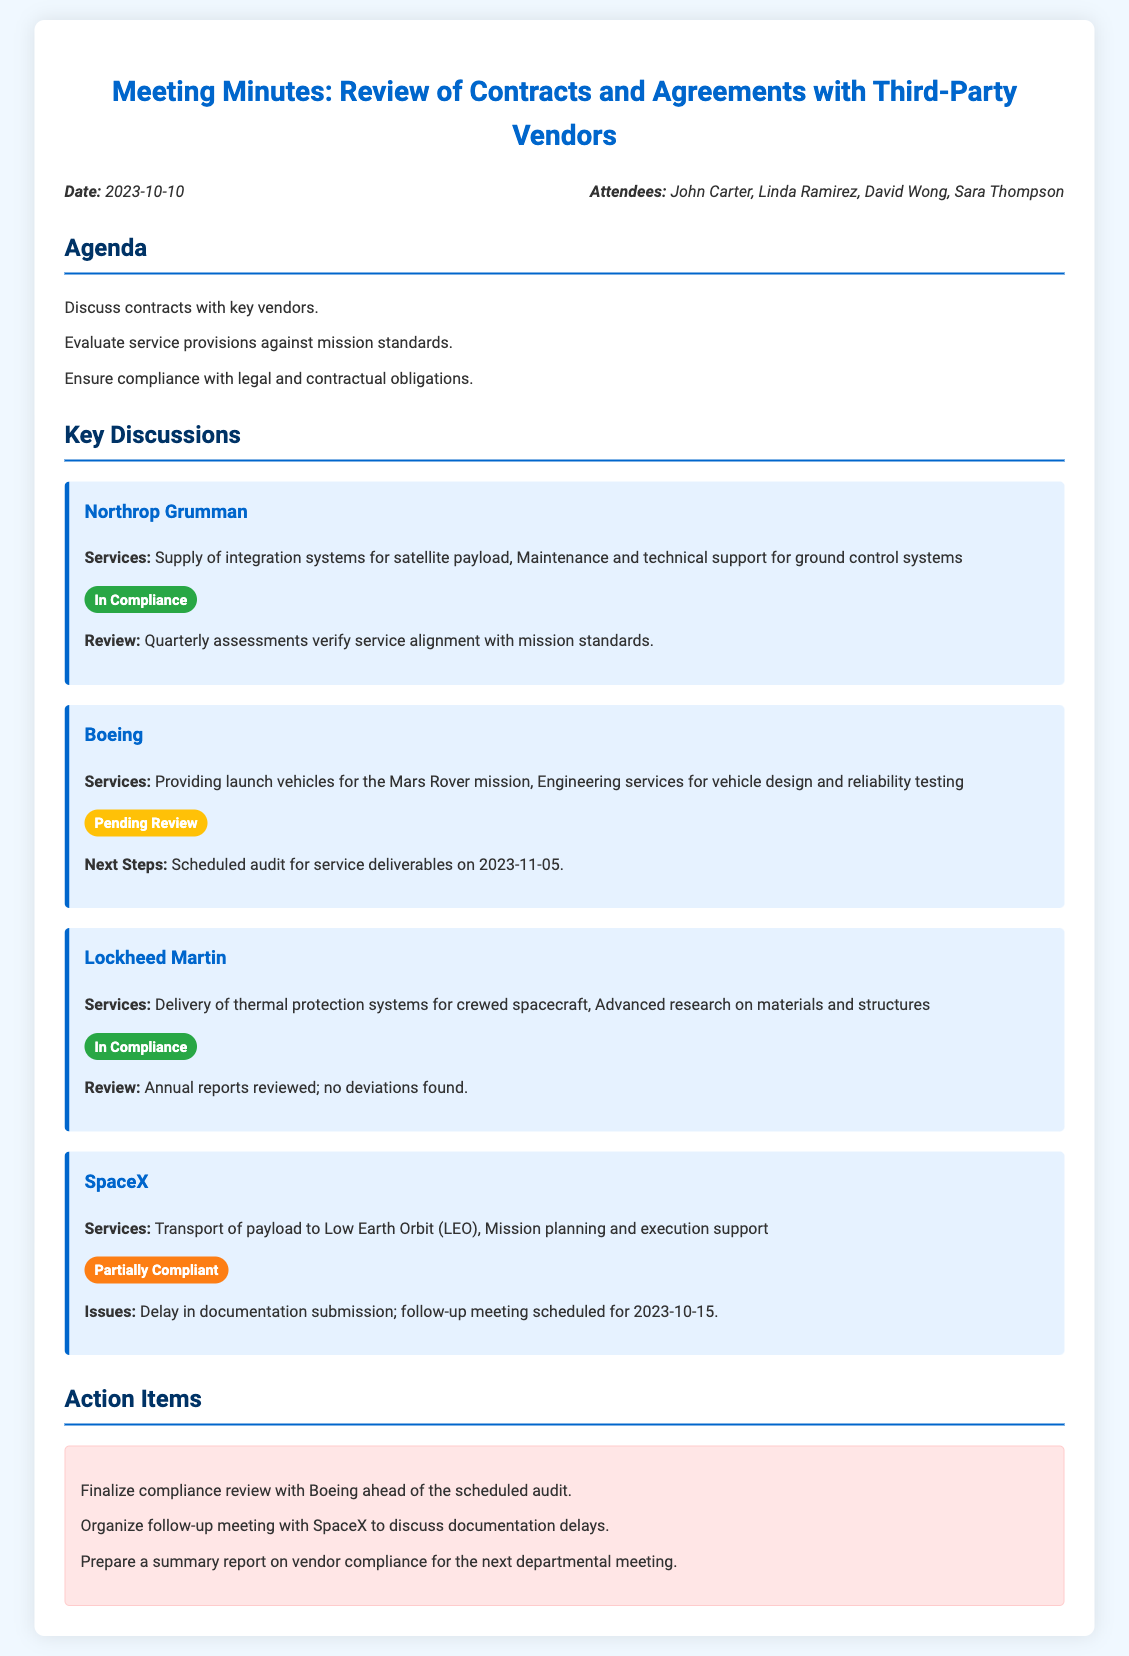What is the date of the meeting? The date of the meeting is stated at the beginning of the document.
Answer: 2023-10-10 Who are the attendees of the meeting? The attendees are listed right after the meeting date.
Answer: John Carter, Linda Ramirez, David Wong, Sara Thompson Which vendor is scheduled for an audit on 2023-11-05? The document specifies which vendor has a scheduled audit.
Answer: Boeing What is the status of SpaceX's compliance? The compliance status of SpaceX is mentioned under the vendor section.
Answer: Partially Compliant How often are assessments conducted for Northrop Grumman? The review frequency is noted in the key discussion section for this vendor.
Answer: Quarterly What services does Lockheed Martin provide? The services offered by Lockheed Martin are detailed in the vendor section.
Answer: Delivery of thermal protection systems for crewed spacecraft, Advanced research on materials and structures What are the next steps for Boeing? The next steps for Boeing are outlined after their service review.
Answer: Scheduled audit for service deliverables on 2023-11-05 What issue is noted with SpaceX services? The document indicates a specific issue faced with SpaceX's services.
Answer: Delay in documentation submission What should be prepared for the next departmental meeting? The action items section specifies what needs to be prepared.
Answer: Summary report on vendor compliance 